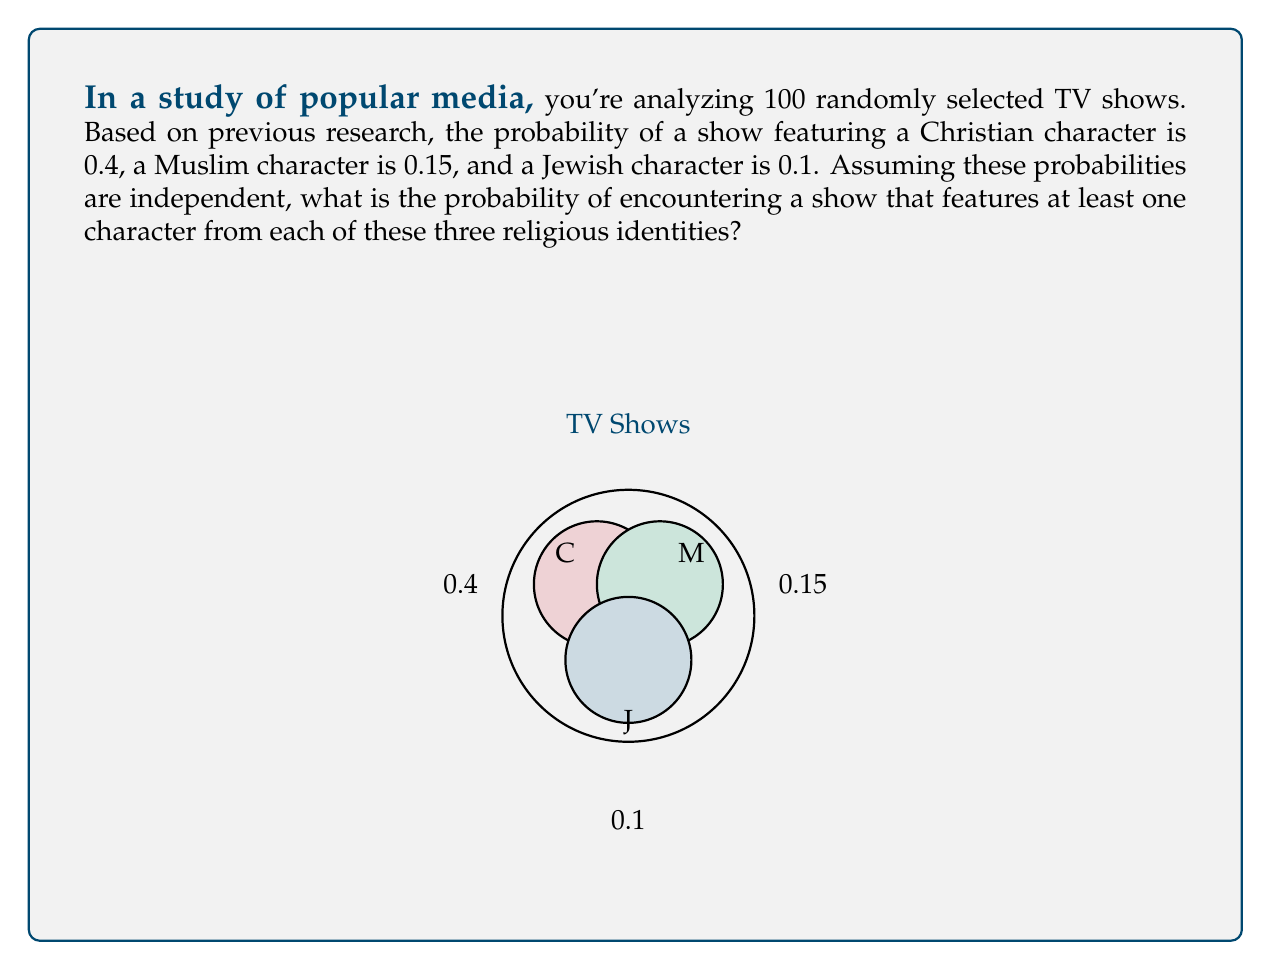Help me with this question. Let's approach this step-by-step:

1) First, we need to understand what the question is asking. We're looking for the probability of a show having all three religious identities represented.

2) Let's define our events:
   C: Show features a Christian character
   M: Show features a Muslim character
   J: Show features a Jewish character

3) We're told that these events are independent, so we can multiply their probabilities:

   $P(C) = 0.4$
   $P(M) = 0.15$
   $P(J) = 0.1$

4) We want the probability of C and M and J occurring together:

   $P(C \cap M \cap J) = P(C) \times P(M) \times P(J)$

5) Substituting the values:

   $P(C \cap M \cap J) = 0.4 \times 0.15 \times 0.1$

6) Calculating:

   $P(C \cap M \cap J) = 0.006$

7) Therefore, the probability of a show featuring at least one character from each of these three religious identities is 0.006 or 0.6%.
Answer: $0.006$ or $0.6\%$ 